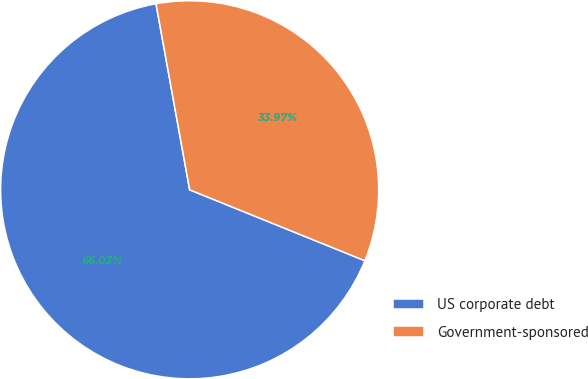Convert chart. <chart><loc_0><loc_0><loc_500><loc_500><pie_chart><fcel>US corporate debt<fcel>Government-sponsored<nl><fcel>66.03%<fcel>33.97%<nl></chart> 